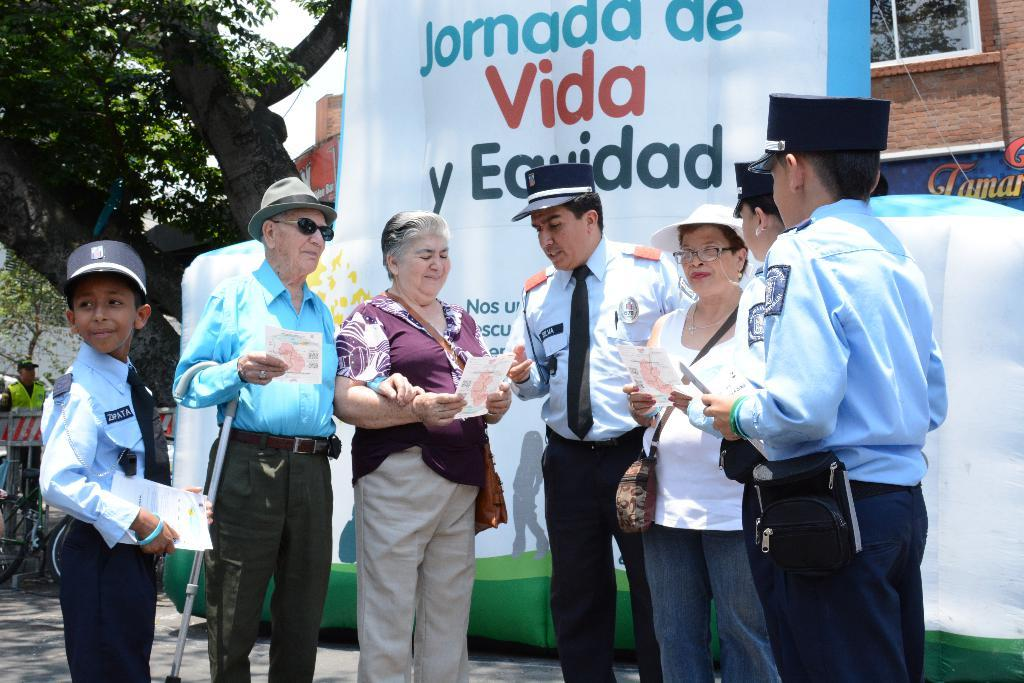What are the people in the image holding? The people in the image are holding papers. What can be seen in the background of the image? There is a hoarding, a building with a window, a person, and a tree in the background of the image. How many people are visible in the image? There are people standing in the image, but the exact number is not specified. What type of fuel is being used by the truck in the image? There is no truck present in the image, so it is not possible to determine what type of fuel is being used. 